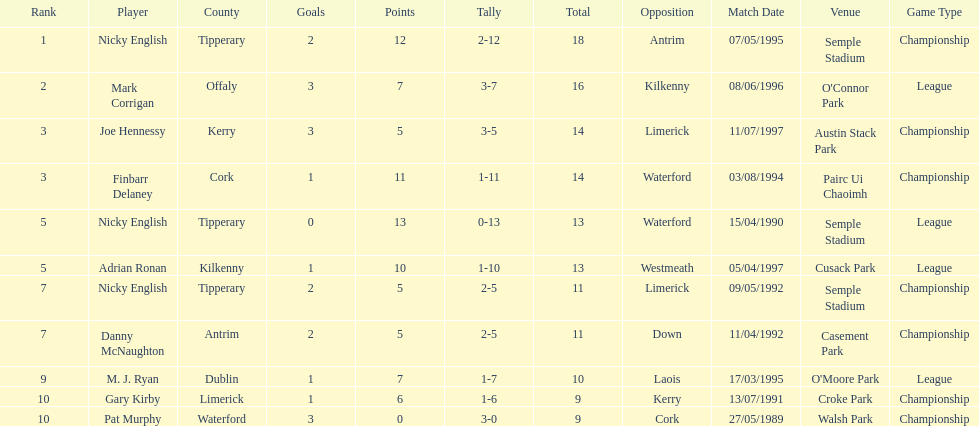Would you mind parsing the complete table? {'header': ['Rank', 'Player', 'County', 'Goals', 'Points', 'Tally', 'Total', 'Opposition', 'Match Date', 'Venue', 'Game Type'], 'rows': [['1', 'Nicky English', 'Tipperary', '2', '12', '2-12', '18', 'Antrim', '07/05/1995', 'Semple Stadium', 'Championship'], ['2', 'Mark Corrigan', 'Offaly', '3', '7', '3-7', '16', 'Kilkenny', '08/06/1996', "O'Connor Park", 'League'], ['3', 'Joe Hennessy', 'Kerry', '3', '5', '3-5', '14', 'Limerick', '11/07/1997', 'Austin Stack Park', 'Championship'], ['3', 'Finbarr Delaney', 'Cork', '1', '11', '1-11', '14', 'Waterford', '03/08/1994', 'Pairc Ui Chaoimh', 'Championship'], ['5', 'Nicky English', 'Tipperary', '0', '13', '0-13', '13', 'Waterford', '15/04/1990', 'Semple Stadium', 'League'], ['5', 'Adrian Ronan', 'Kilkenny', '1', '10', '1-10', '13', 'Westmeath', '05/04/1997', 'Cusack Park', 'League'], ['7', 'Nicky English', 'Tipperary', '2', '5', '2-5', '11', 'Limerick', '09/05/1992', 'Semple Stadium', 'Championship'], ['7', 'Danny McNaughton', 'Antrim', '2', '5', '2-5', '11', 'Down', '11/04/1992', 'Casement Park', 'Championship'], ['9', 'M. J. Ryan', 'Dublin', '1', '7', '1-7', '10', 'Laois', '17/03/1995', "O'Moore Park", 'League'], ['10', 'Gary Kirby', 'Limerick', '1', '6', '1-6', '9', 'Kerry', '13/07/1991', 'Croke Park', 'Championship'], ['10', 'Pat Murphy', 'Waterford', '3', '0', '3-0', '9', 'Cork', '27/05/1989', 'Walsh Park', 'Championship']]} Which player ranked the most? Nicky English. 